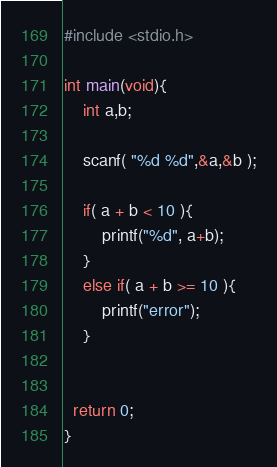Convert code to text. <code><loc_0><loc_0><loc_500><loc_500><_C_>#include <stdio.h>

int main(void){
    int a,b;
    
    scanf( "%d %d",&a,&b );
    
    if( a + b < 10 ){
        printf("%d", a+b);
    }
    else if( a + b >= 10 ){
        printf("error");
    }

    
  return 0;
}</code> 